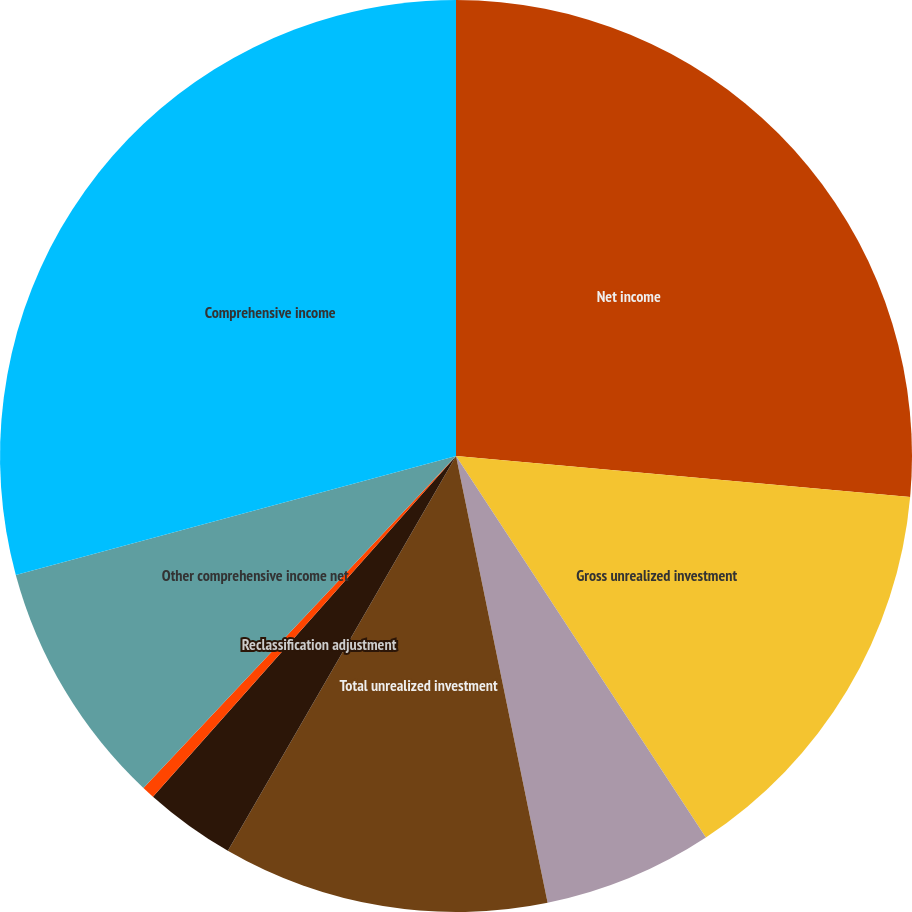Convert chart to OTSL. <chart><loc_0><loc_0><loc_500><loc_500><pie_chart><fcel>Net income<fcel>Gross unrealized investment<fcel>Effect of income taxes<fcel>Total unrealized investment<fcel>Reclassification adjustment<fcel>Total reclassification<fcel>Other comprehensive income net<fcel>Comprehensive income<nl><fcel>26.43%<fcel>14.34%<fcel>6.01%<fcel>11.56%<fcel>3.23%<fcel>0.45%<fcel>8.78%<fcel>29.2%<nl></chart> 